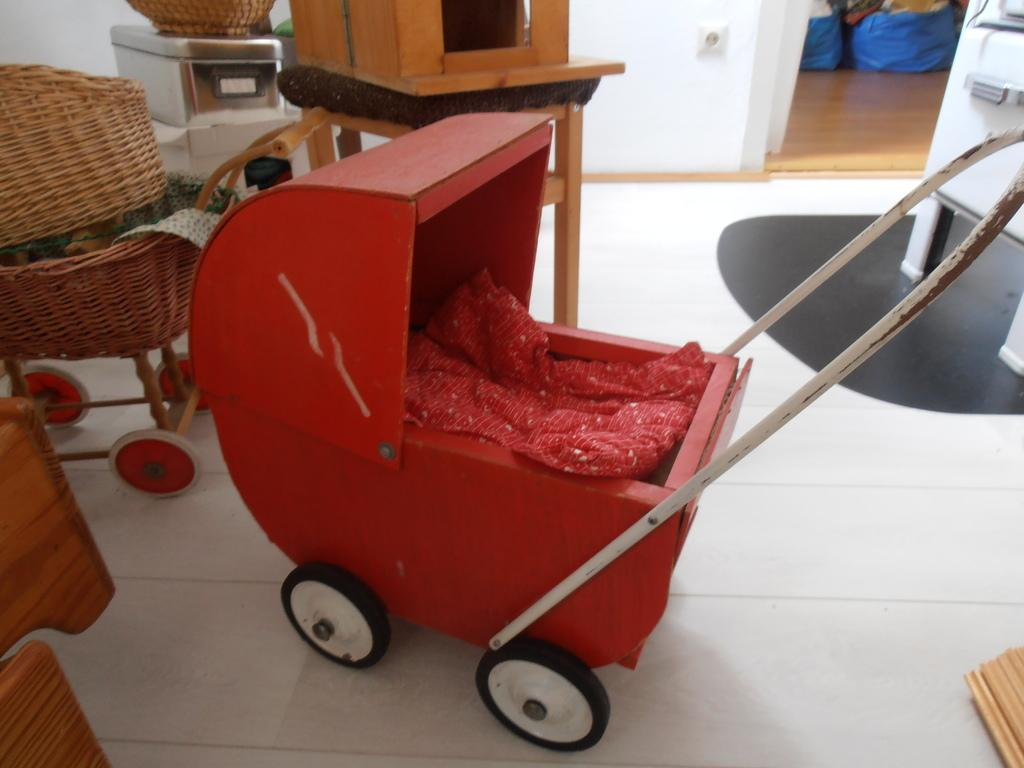How many baby carriages are in the image? There are two baby carriages in the image. Can you describe any items visible in the background of the image? Unfortunately, the provided facts do not give any information about the items visible in the background of the image. What committee is meeting in the lunchroom in the image? There is no committee meeting in a lunchroom in the image, as the provided facts only mention two baby carriages and items visible in the background. 